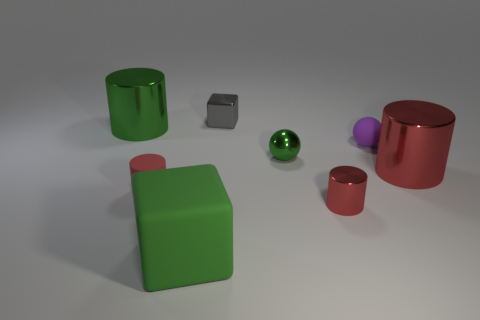Subtract all purple blocks. How many red cylinders are left? 3 Subtract all cyan cylinders. Subtract all red blocks. How many cylinders are left? 4 Add 1 small blue metal blocks. How many objects exist? 9 Subtract all balls. How many objects are left? 6 Subtract 0 blue cylinders. How many objects are left? 8 Subtract all tiny rubber spheres. Subtract all tiny metal cylinders. How many objects are left? 6 Add 6 big green blocks. How many big green blocks are left? 7 Add 5 purple matte spheres. How many purple matte spheres exist? 6 